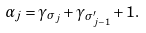<formula> <loc_0><loc_0><loc_500><loc_500>\alpha _ { j } = \gamma _ { \sigma _ { j } } + \gamma _ { \sigma _ { j - 1 } ^ { \prime } } + 1 .</formula> 